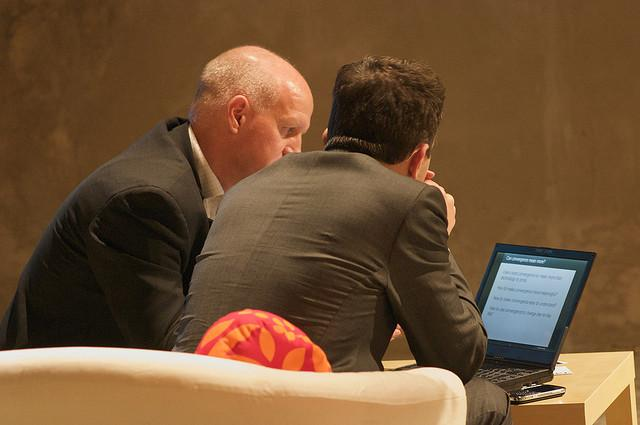What type of battery is best for laptop? lithium 